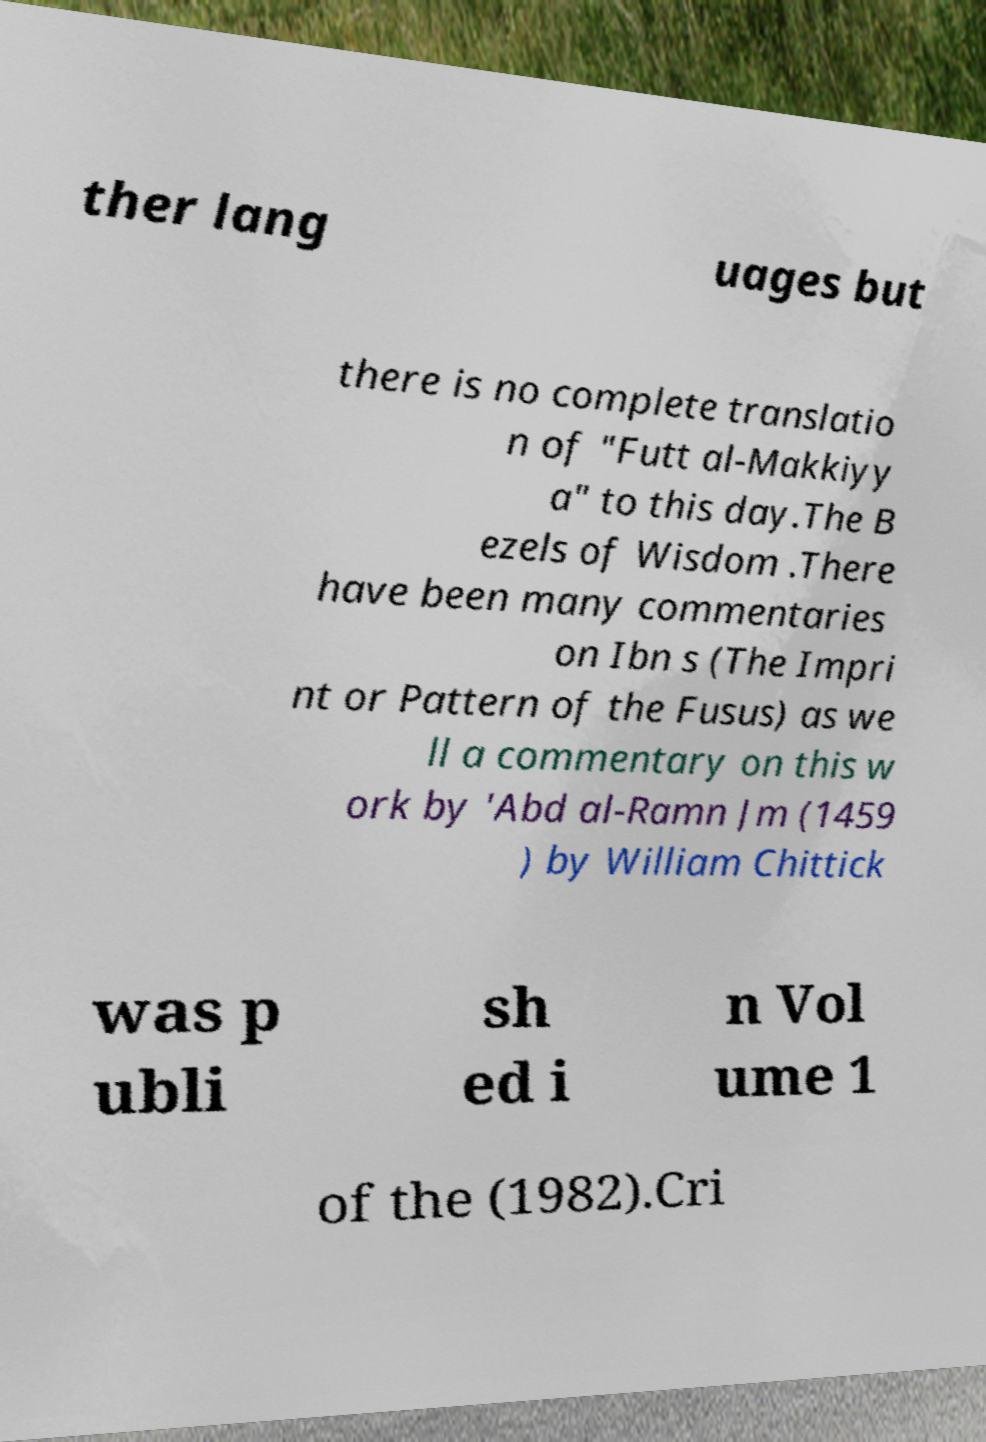Please read and relay the text visible in this image. What does it say? ther lang uages but there is no complete translatio n of "Futt al-Makkiyy a" to this day.The B ezels of Wisdom .There have been many commentaries on Ibn s (The Impri nt or Pattern of the Fusus) as we ll a commentary on this w ork by 'Abd al-Ramn Jm (1459 ) by William Chittick was p ubli sh ed i n Vol ume 1 of the (1982).Cri 